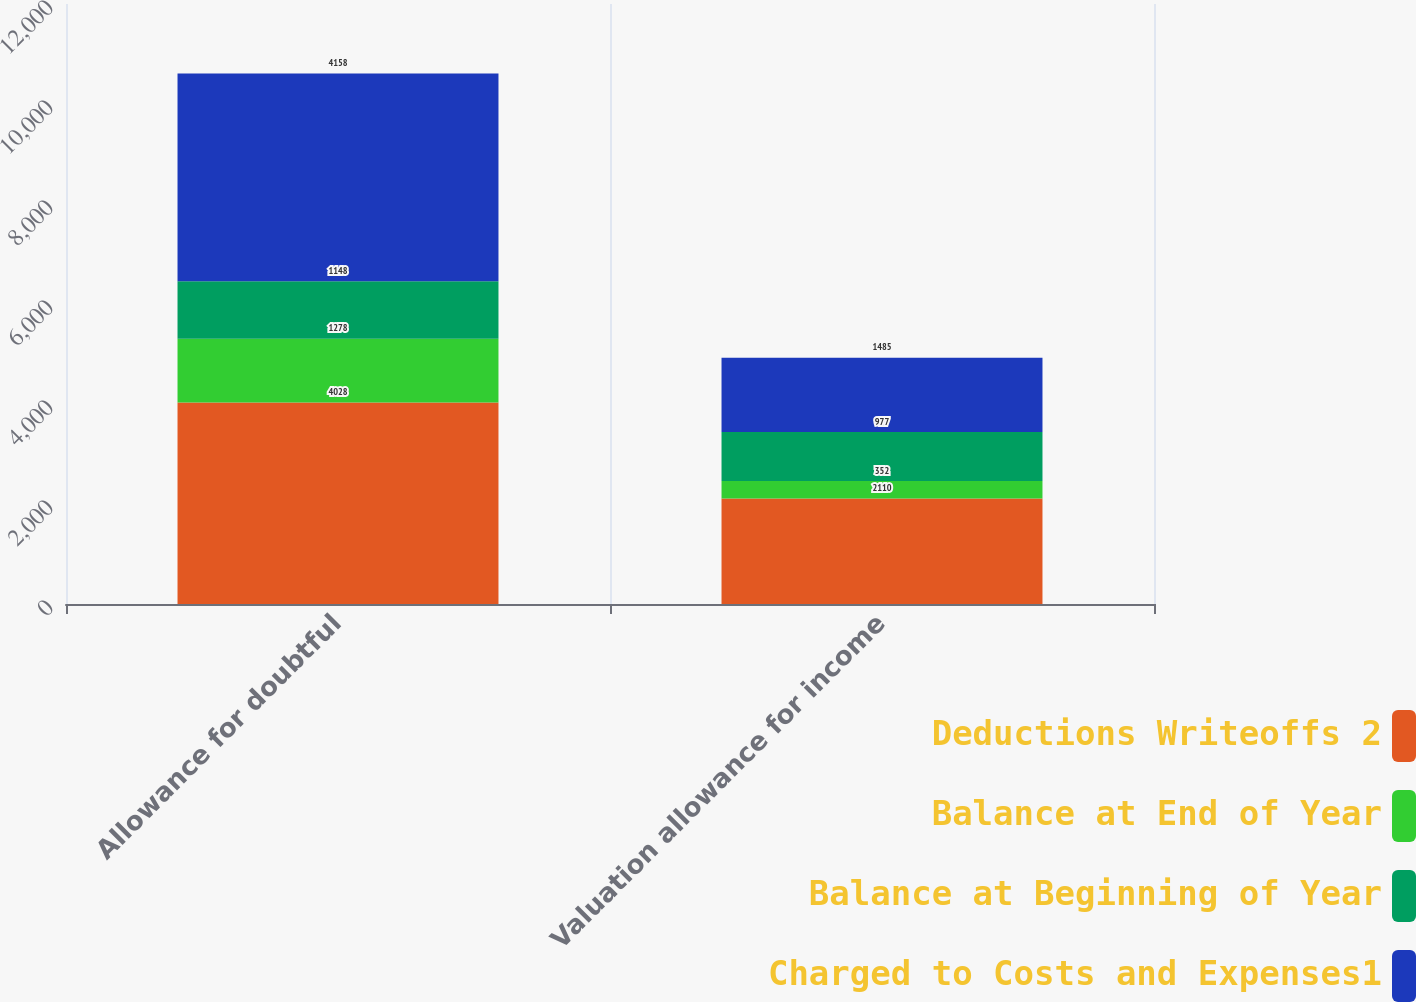Convert chart to OTSL. <chart><loc_0><loc_0><loc_500><loc_500><stacked_bar_chart><ecel><fcel>Allowance for doubtful<fcel>Valuation allowance for income<nl><fcel>Deductions Writeoffs 2<fcel>4028<fcel>2110<nl><fcel>Balance at End of Year<fcel>1278<fcel>352<nl><fcel>Balance at Beginning of Year<fcel>1148<fcel>977<nl><fcel>Charged to Costs and Expenses1<fcel>4158<fcel>1485<nl></chart> 